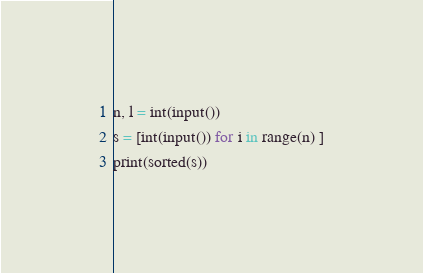Convert code to text. <code><loc_0><loc_0><loc_500><loc_500><_Python_>n, l = int(input())
s = [int(input()) for i in range(n) ]
print(sorted(s))</code> 